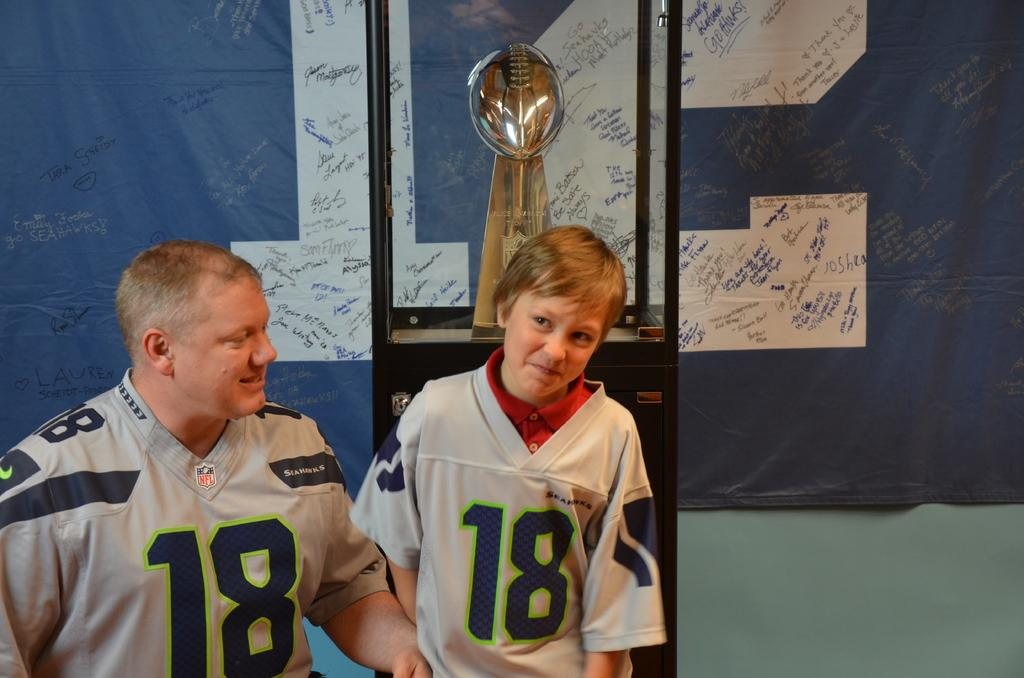<image>
Provide a brief description of the given image. a couple people that are wearing the number 18 